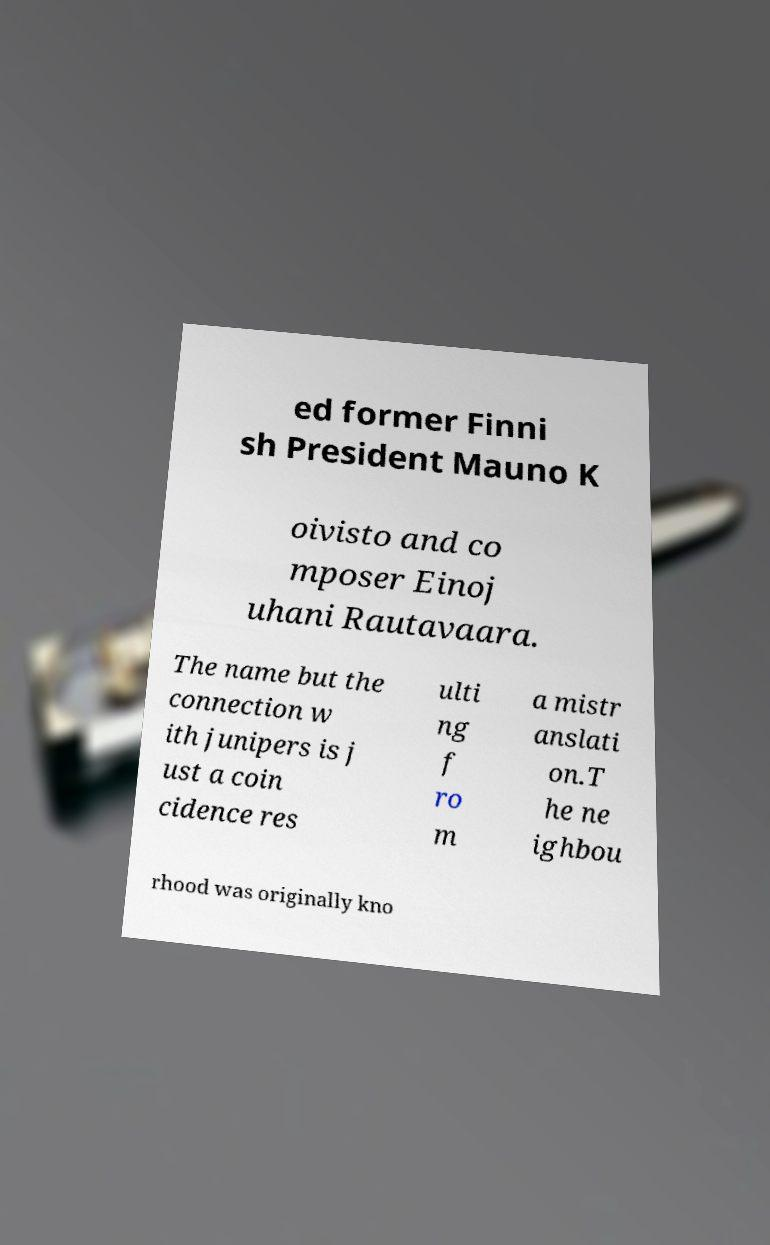Could you extract and type out the text from this image? ed former Finni sh President Mauno K oivisto and co mposer Einoj uhani Rautavaara. The name but the connection w ith junipers is j ust a coin cidence res ulti ng f ro m a mistr anslati on.T he ne ighbou rhood was originally kno 